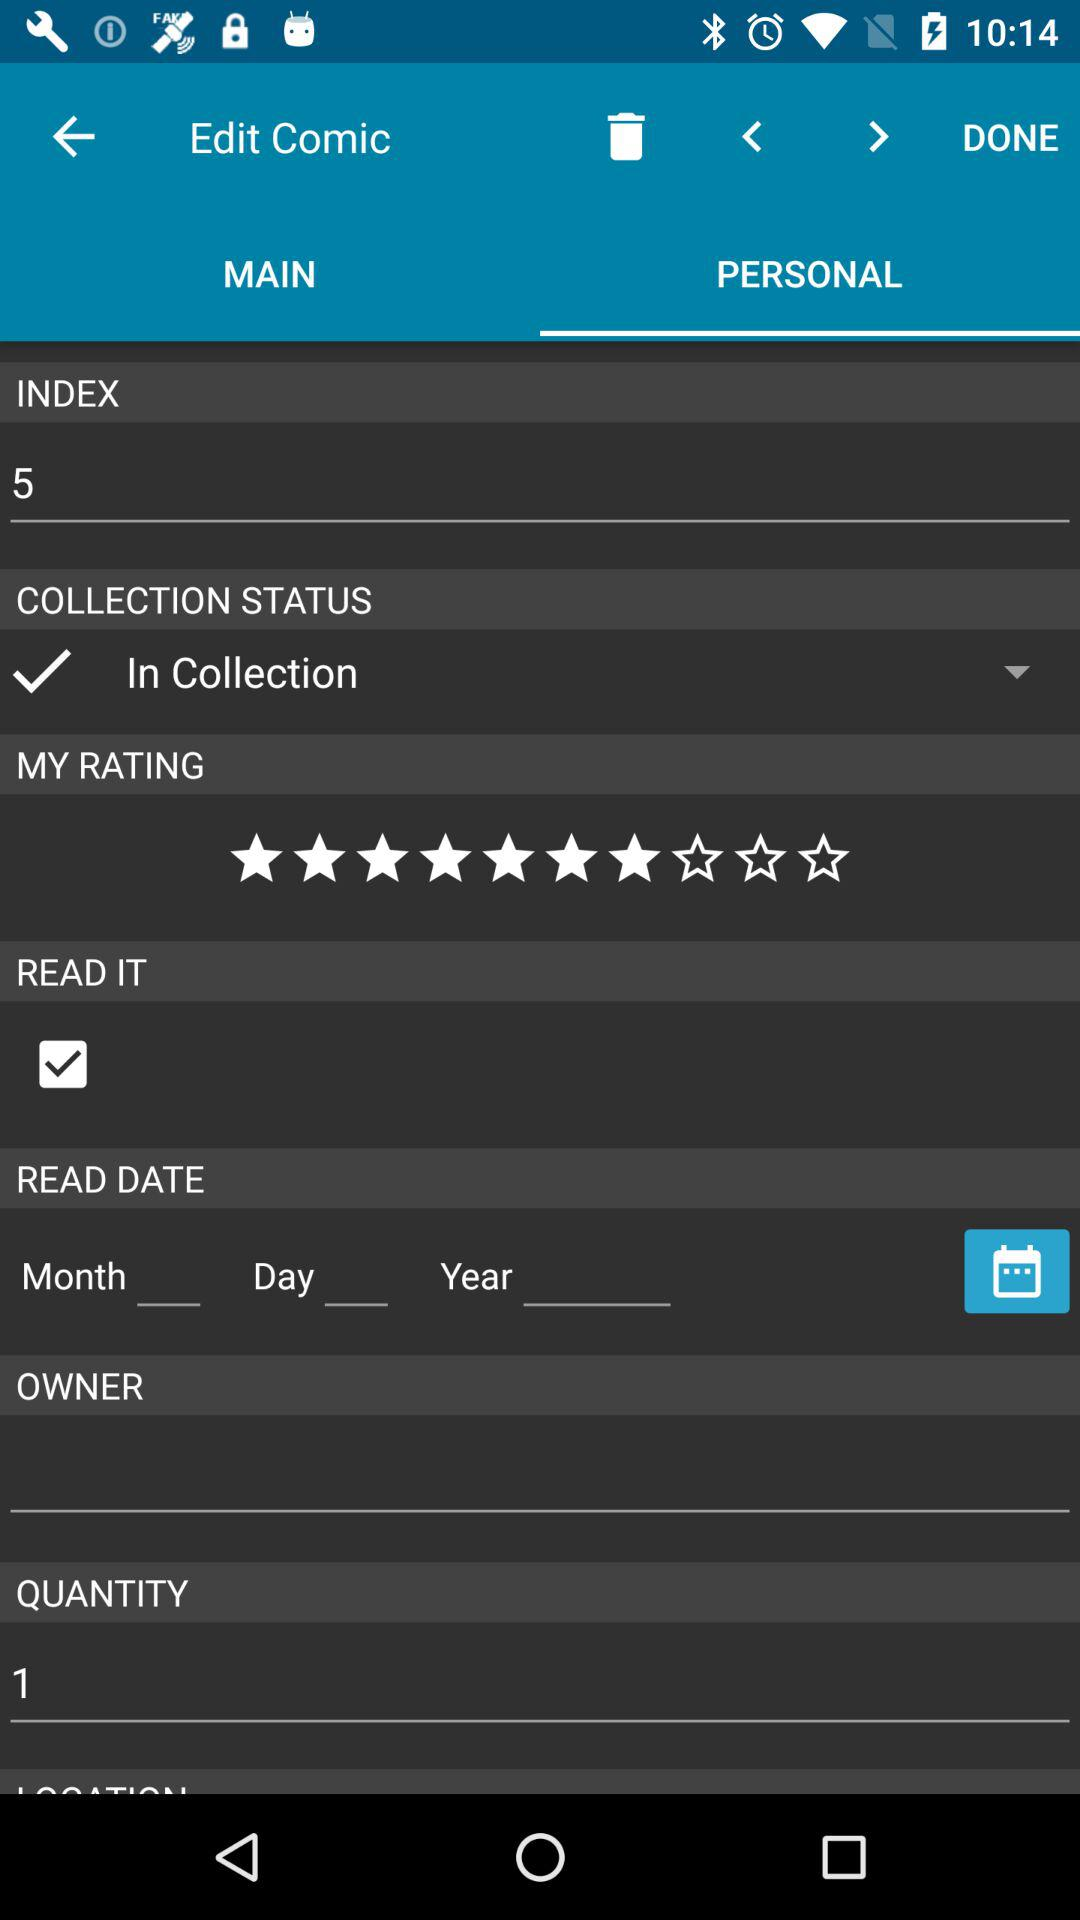What is the total number of indexes in the comic? The total number of indexes in the comic is 5. 